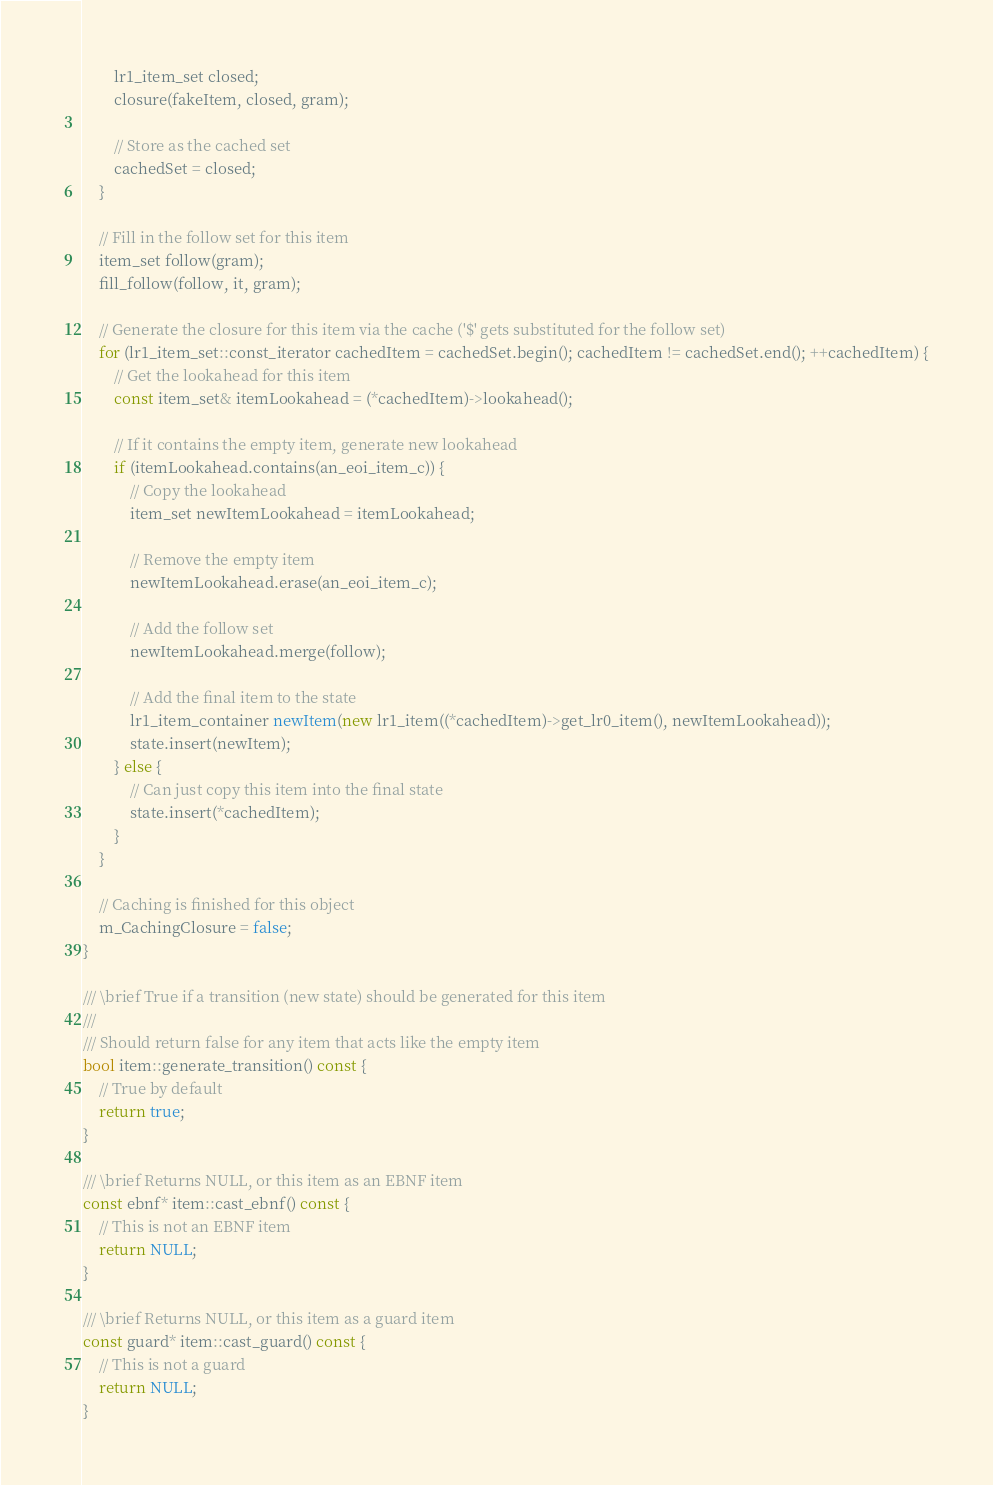<code> <loc_0><loc_0><loc_500><loc_500><_C++_>        lr1_item_set closed;
        closure(fakeItem, closed, gram);
        
        // Store as the cached set
        cachedSet = closed;
    }
    
    // Fill in the follow set for this item
    item_set follow(gram);
    fill_follow(follow, it, gram);
    
    // Generate the closure for this item via the cache ('$' gets substituted for the follow set)
    for (lr1_item_set::const_iterator cachedItem = cachedSet.begin(); cachedItem != cachedSet.end(); ++cachedItem) {
        // Get the lookahead for this item
        const item_set& itemLookahead = (*cachedItem)->lookahead();
        
        // If it contains the empty item, generate new lookahead
        if (itemLookahead.contains(an_eoi_item_c)) {
            // Copy the lookahead
            item_set newItemLookahead = itemLookahead;
            
            // Remove the empty item
            newItemLookahead.erase(an_eoi_item_c);
            
            // Add the follow set
            newItemLookahead.merge(follow);
            
            // Add the final item to the state
            lr1_item_container newItem(new lr1_item((*cachedItem)->get_lr0_item(), newItemLookahead));
            state.insert(newItem);
        } else {
            // Can just copy this item into the final state
            state.insert(*cachedItem);
        }
    }
    
    // Caching is finished for this object
    m_CachingClosure = false;
}

/// \brief True if a transition (new state) should be generated for this item
///
/// Should return false for any item that acts like the empty item
bool item::generate_transition() const {
    // True by default
    return true;
}

/// \brief Returns NULL, or this item as an EBNF item
const ebnf* item::cast_ebnf() const {
    // This is not an EBNF item
    return NULL;
}

/// \brief Returns NULL, or this item as a guard item
const guard* item::cast_guard() const {
    // This is not a guard
    return NULL;
}
</code> 